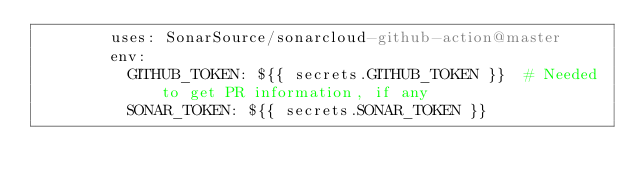<code> <loc_0><loc_0><loc_500><loc_500><_YAML_>        uses: SonarSource/sonarcloud-github-action@master
        env:
          GITHUB_TOKEN: ${{ secrets.GITHUB_TOKEN }}  # Needed to get PR information, if any
          SONAR_TOKEN: ${{ secrets.SONAR_TOKEN }}</code> 